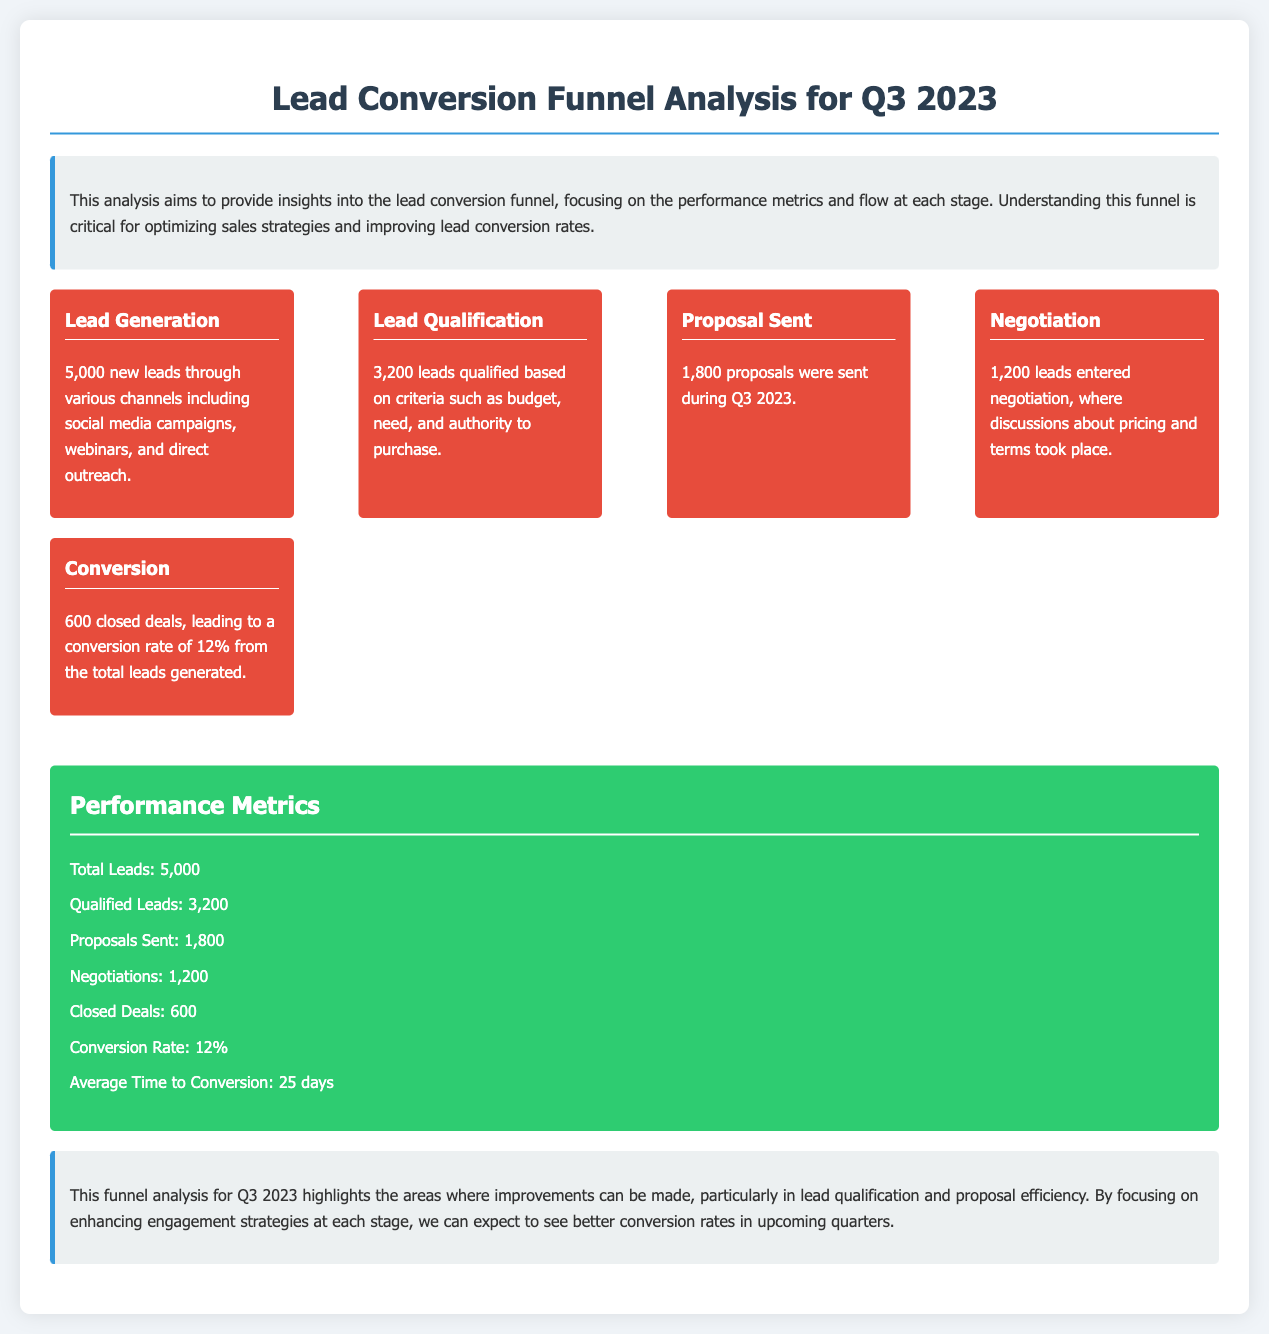What was the total number of new leads generated? The document states that 5,000 new leads were generated through various channels.
Answer: 5,000 How many leads were qualified? The document mentions that 3,200 leads were qualified based on specific criteria.
Answer: 3,200 What is the conversion rate? According to the document, the conversion rate is based on the closed deals related to the total leads generated.
Answer: 12% How many proposals were sent during Q3 2023? The document specifies that 1,800 proposals were sent in this period.
Answer: 1,800 What is the average time to conversion? The document indicates that the average time to conversion is 25 days.
Answer: 25 days Which stage in the funnel had the most leads? The document shows that the lead generation stage had the highest number of leads at 5,000.
Answer: Lead Generation What insights does the conclusion highlight for improvement? The conclusion points out that improvements are needed particularly in lead qualification and proposal efficiency.
Answer: Lead qualification and proposal efficiency What is the total number of closed deals? The document indicates that there were 600 closed deals during Q3 2023.
Answer: 600 